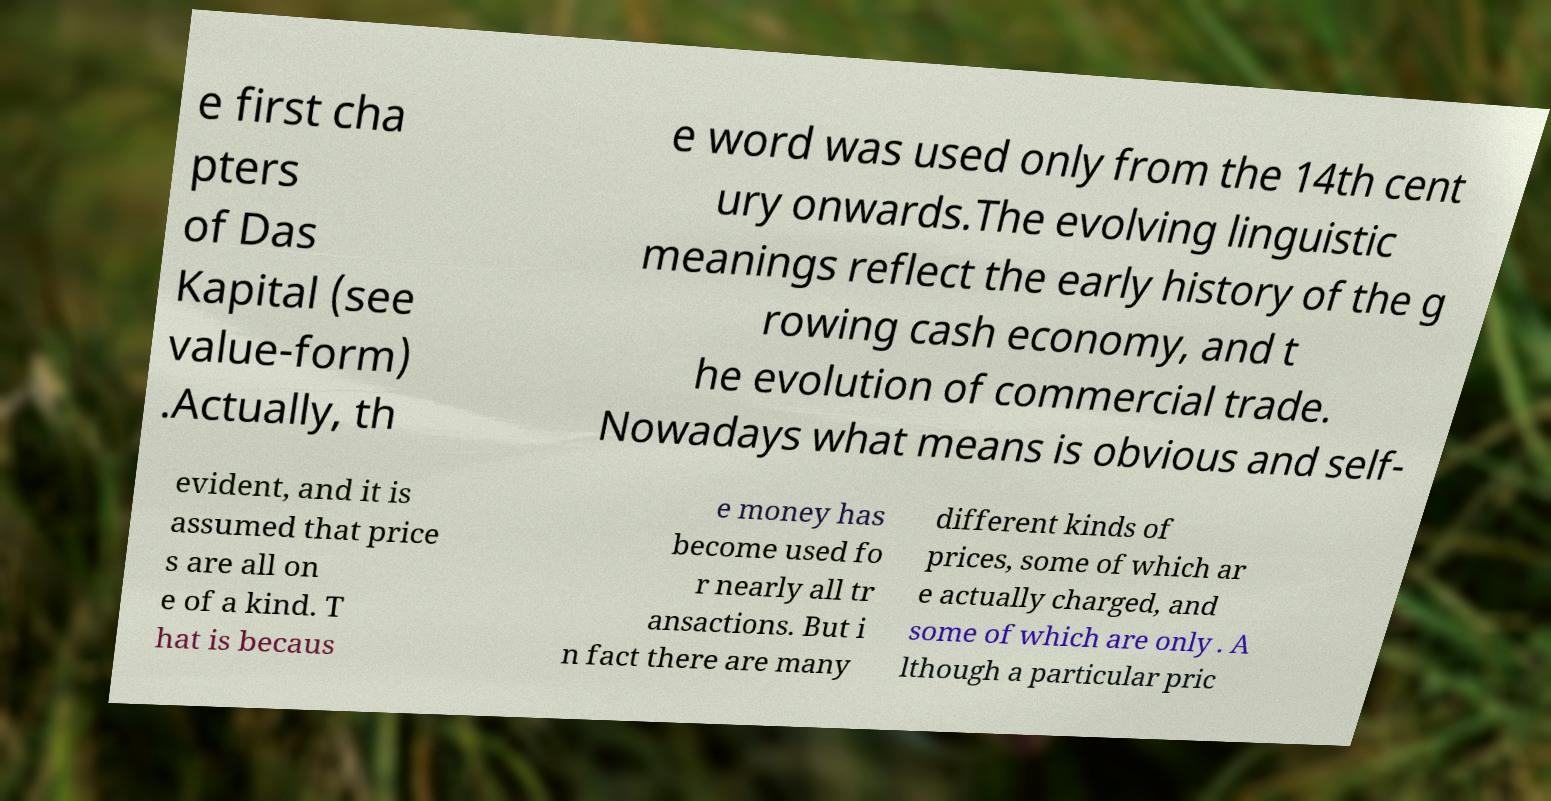I need the written content from this picture converted into text. Can you do that? e first cha pters of Das Kapital (see value-form) .Actually, th e word was used only from the 14th cent ury onwards.The evolving linguistic meanings reflect the early history of the g rowing cash economy, and t he evolution of commercial trade. Nowadays what means is obvious and self- evident, and it is assumed that price s are all on e of a kind. T hat is becaus e money has become used fo r nearly all tr ansactions. But i n fact there are many different kinds of prices, some of which ar e actually charged, and some of which are only . A lthough a particular pric 